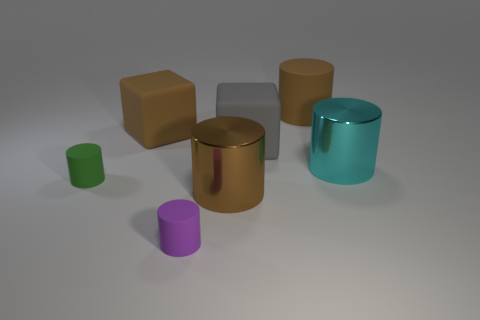Subtract all gray cubes. How many brown cylinders are left? 2 Subtract all tiny cylinders. How many cylinders are left? 3 Add 3 large matte things. How many objects exist? 10 Subtract all brown cylinders. How many cylinders are left? 3 Subtract all cylinders. How many objects are left? 2 Subtract 2 cylinders. How many cylinders are left? 3 Subtract all yellow cylinders. Subtract all brown spheres. How many cylinders are left? 5 Subtract all brown blocks. Subtract all big brown matte objects. How many objects are left? 4 Add 1 big metallic cylinders. How many big metallic cylinders are left? 3 Add 1 small green cylinders. How many small green cylinders exist? 2 